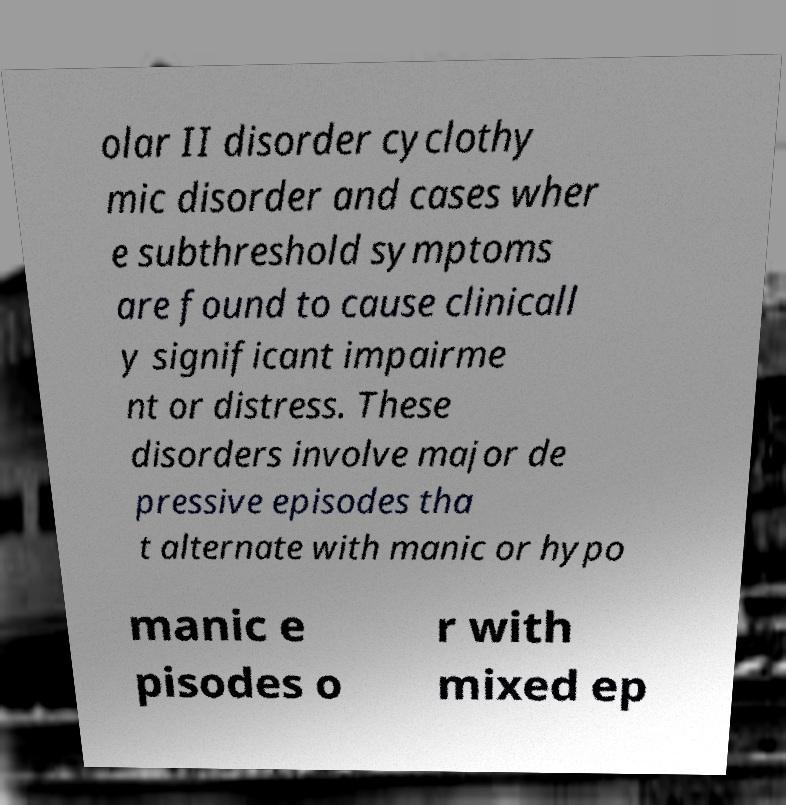What messages or text are displayed in this image? I need them in a readable, typed format. olar II disorder cyclothy mic disorder and cases wher e subthreshold symptoms are found to cause clinicall y significant impairme nt or distress. These disorders involve major de pressive episodes tha t alternate with manic or hypo manic e pisodes o r with mixed ep 